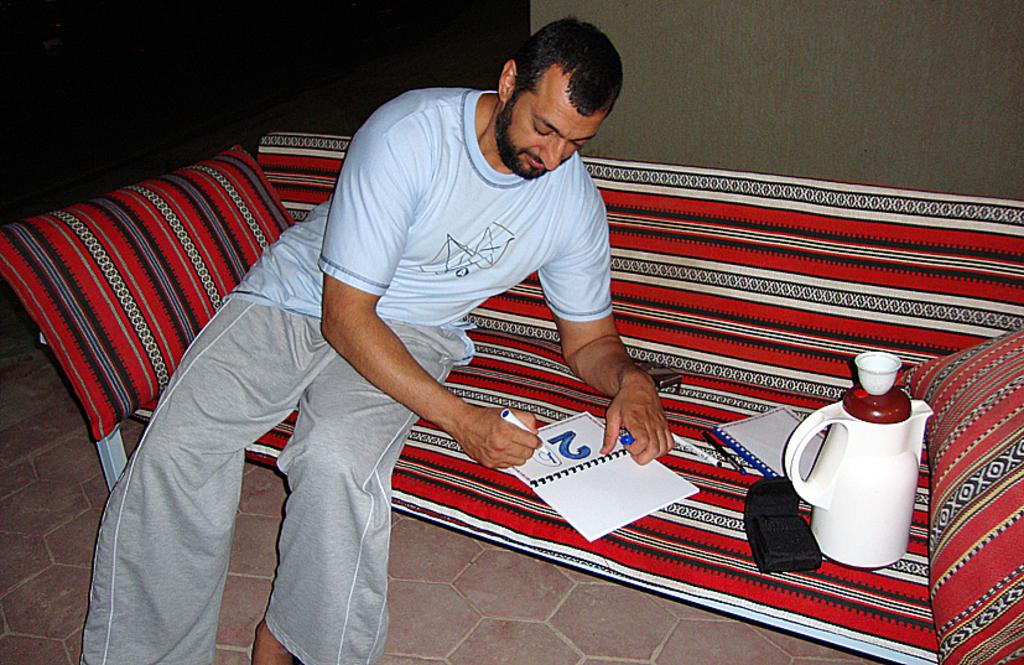<image>
Offer a succinct explanation of the picture presented. a man is coloring in the numbers 29 in a book 